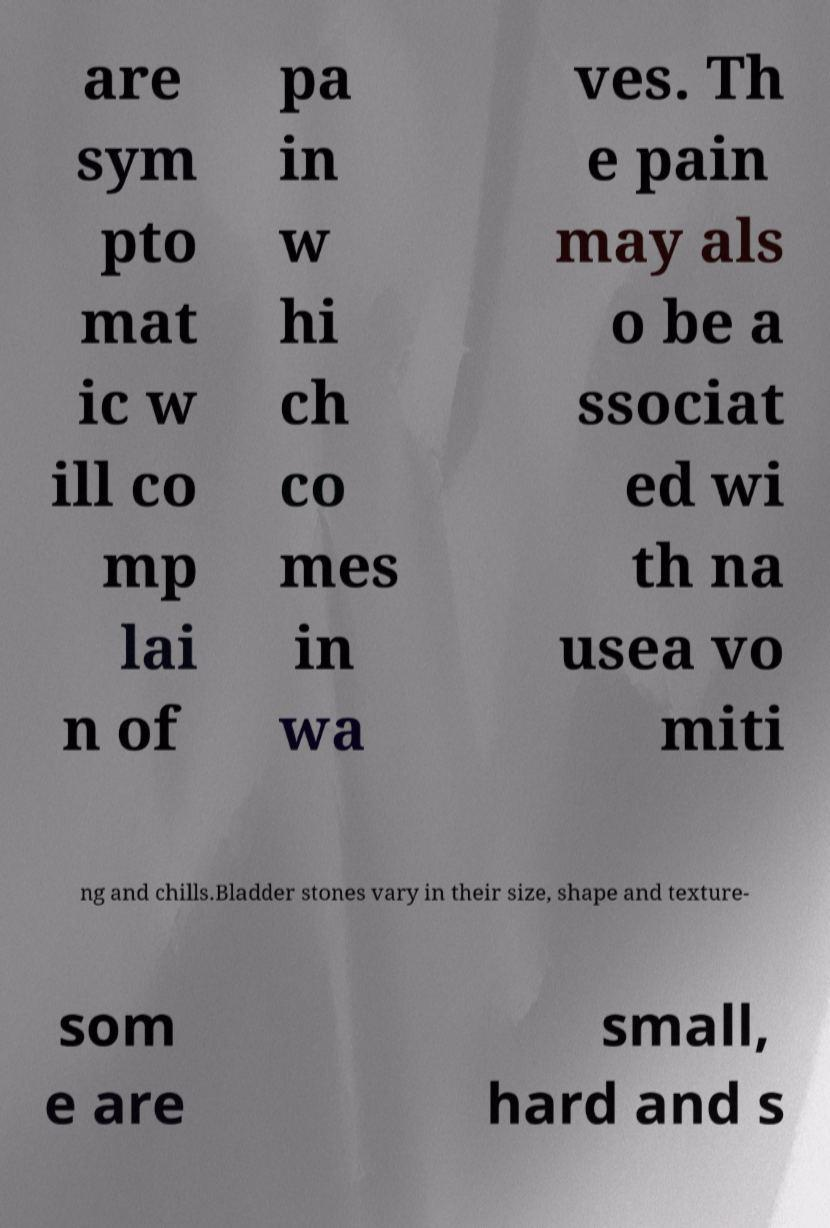There's text embedded in this image that I need extracted. Can you transcribe it verbatim? are sym pto mat ic w ill co mp lai n of pa in w hi ch co mes in wa ves. Th e pain may als o be a ssociat ed wi th na usea vo miti ng and chills.Bladder stones vary in their size, shape and texture- som e are small, hard and s 